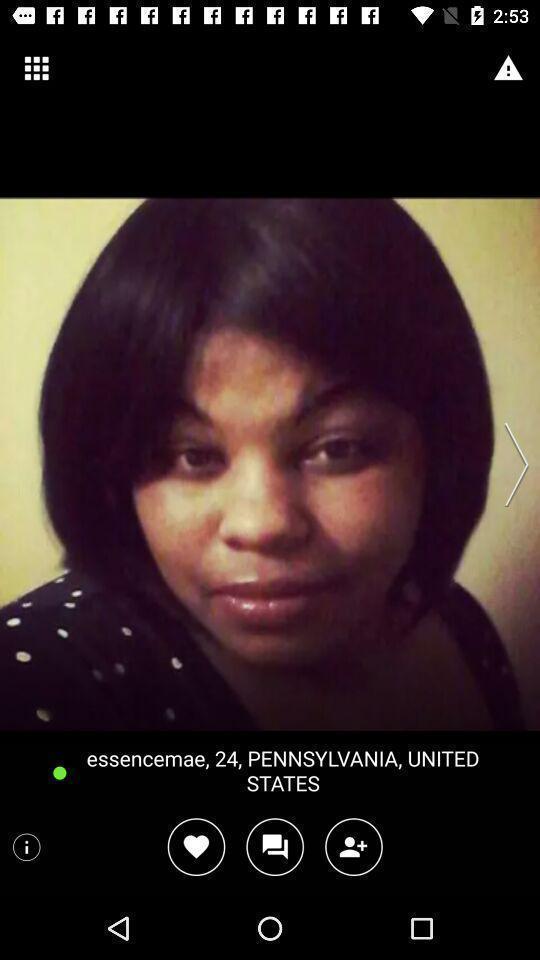Provide a detailed account of this screenshot. Screen shows an image of women and location. 